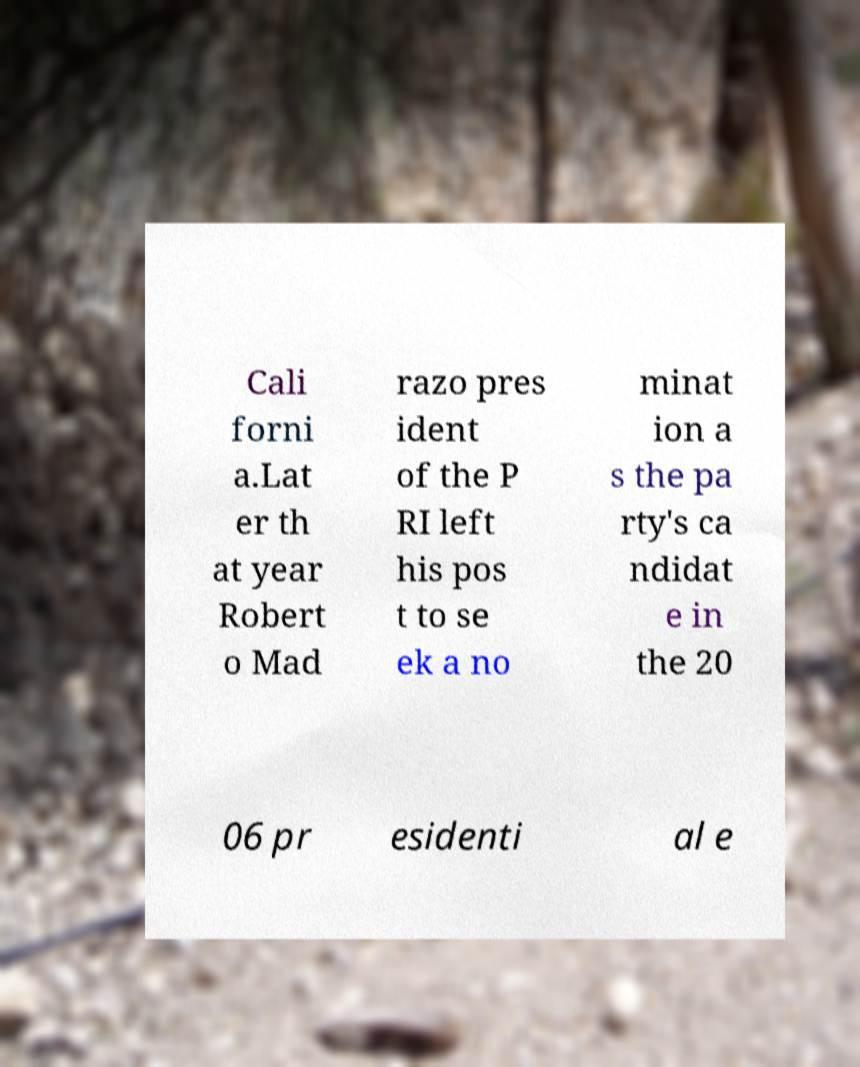Can you read and provide the text displayed in the image?This photo seems to have some interesting text. Can you extract and type it out for me? Cali forni a.Lat er th at year Robert o Mad razo pres ident of the P RI left his pos t to se ek a no minat ion a s the pa rty's ca ndidat e in the 20 06 pr esidenti al e 